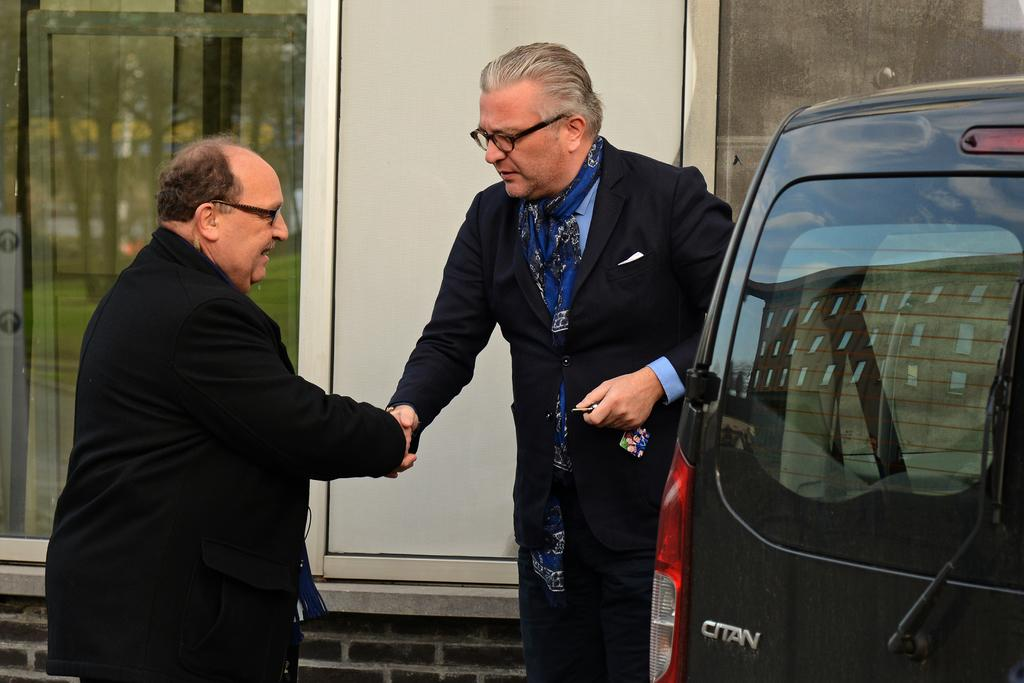How many people are in the image? There are two people in the image. What are the two people doing? The two people are shaking hands. What can be seen beside the people? There is a car beside the people. What is visible on the wall in the image? There are windows on the wall. What time of day is it in the image, given the minute hand on the clock? There is no clock or minute hand present in the image, so it cannot be determined from the image. 